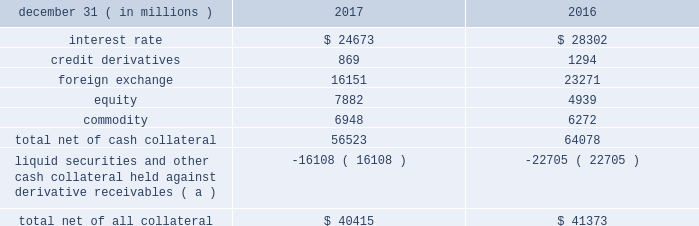Management 2019s discussion and analysis 114 jpmorgan chase & co./2017 annual report derivative contracts in the normal course of business , the firm uses derivative instruments predominantly for market-making activities .
Derivatives enable counterparties to manage exposures to fluctuations in interest rates , currencies and other markets .
The firm also uses derivative instruments to manage its own credit and other market risk exposure .
The nature of the counterparty and the settlement mechanism of the derivative affect the credit risk to which the firm is exposed .
For otc derivatives the firm is exposed to the credit risk of the derivative counterparty .
For exchange- traded derivatives ( 201cetd 201d ) , such as futures and options , and 201ccleared 201d over-the-counter ( 201cotc-cleared 201d ) derivatives , the firm is generally exposed to the credit risk of the relevant ccp .
Where possible , the firm seeks to mitigate its credit risk exposures arising from derivative transactions through the use of legally enforceable master netting arrangements and collateral agreements .
For further discussion of derivative contracts , counterparties and settlement types , see note 5 .
The table summarizes the net derivative receivables for the periods presented .
Derivative receivables .
( a ) includes collateral related to derivative instruments where an appropriate legal opinion has not been either sought or obtained .
Derivative receivables reported on the consolidated balance sheets were $ 56.5 billion and $ 64.1 billion at december 31 , 2017 and 2016 , respectively .
Derivative receivables decreased predominantly as a result of client- driven market-making activities in cib markets , which reduced foreign exchange and interest rate derivative receivables , and increased equity derivative receivables , driven by market movements .
Derivative receivables amounts represent the fair value of the derivative contracts after giving effect to legally enforceable master netting agreements and cash collateral held by the firm .
However , in management 2019s view , the appropriate measure of current credit risk should also take into consideration additional liquid securities ( primarily u.s .
Government and agency securities and other group of seven nations ( 201cg7 201d ) government bonds ) and other cash collateral held by the firm aggregating $ 16.1 billion and $ 22.7 billion at december 31 , 2017 and 2016 , respectively , that may be used as security when the fair value of the client 2019s exposure is in the firm 2019s favor .
In addition to the collateral described in the preceding paragraph , the firm also holds additional collateral ( primarily cash , g7 government securities , other liquid government-agency and guaranteed securities , and corporate debt and equity securities ) delivered by clients at the initiation of transactions , as well as collateral related to contracts that have a non-daily call frequency and collateral that the firm has agreed to return but has not yet settled as of the reporting date .
Although this collateral does not reduce the balances and is not included in the table above , it is available as security against potential exposure that could arise should the fair value of the client 2019s derivative transactions move in the firm 2019s favor .
The derivative receivables fair value , net of all collateral , also does not include other credit enhancements , such as letters of credit .
For additional information on the firm 2019s use of collateral agreements , see note 5 .
While useful as a current view of credit exposure , the net fair value of the derivative receivables does not capture the potential future variability of that credit exposure .
To capture the potential future variability of credit exposure , the firm calculates , on a client-by-client basis , three measures of potential derivatives-related credit loss : peak , derivative risk equivalent ( 201cdre 201d ) , and average exposure ( 201cavg 201d ) .
These measures all incorporate netting and collateral benefits , where applicable .
Peak represents a conservative measure of potential exposure to a counterparty calculated in a manner that is broadly equivalent to a 97.5% ( 97.5 % ) confidence level over the life of the transaction .
Peak is the primary measure used by the firm for setting of credit limits for derivative transactions , senior management reporting and derivatives exposure management .
Dre exposure is a measure that expresses the risk of derivative exposure on a basis intended to be equivalent to the risk of loan exposures .
Dre is a less extreme measure of potential credit loss than peak and is used for aggregating derivative credit risk exposures with loans and other credit risk .
Finally , avg is a measure of the expected fair value of the firm 2019s derivative receivables at future time periods , including the benefit of collateral .
Avg exposure over the total life of the derivative contract is used as the primary metric for pricing purposes and is used to calculate credit risk capital and the cva , as further described below .
The three year avg exposure was $ 29.0 billion and $ 31.1 billion at december 31 , 2017 and 2016 , respectively , compared with derivative receivables , net of all collateral , of $ 40.4 billion and $ 41.4 billion at december 31 , 2017 and 2016 , respectively .
The fair value of the firm 2019s derivative receivables incorporates cva to reflect the credit quality of counterparties .
Cva is based on the firm 2019s avg to a counterparty and the counterparty 2019s credit spread in the credit derivatives market .
The firm believes that active risk management is essential to controlling the dynamic credit risk in the derivatives portfolio .
In addition , the firm 2019s risk management process takes into consideration the potential .
What was the ratio of the derivative receivables reported on the consolidated balance sheets for 2016 to 2017? 
Computations: (64.1 / 56.5)
Answer: 1.13451. 